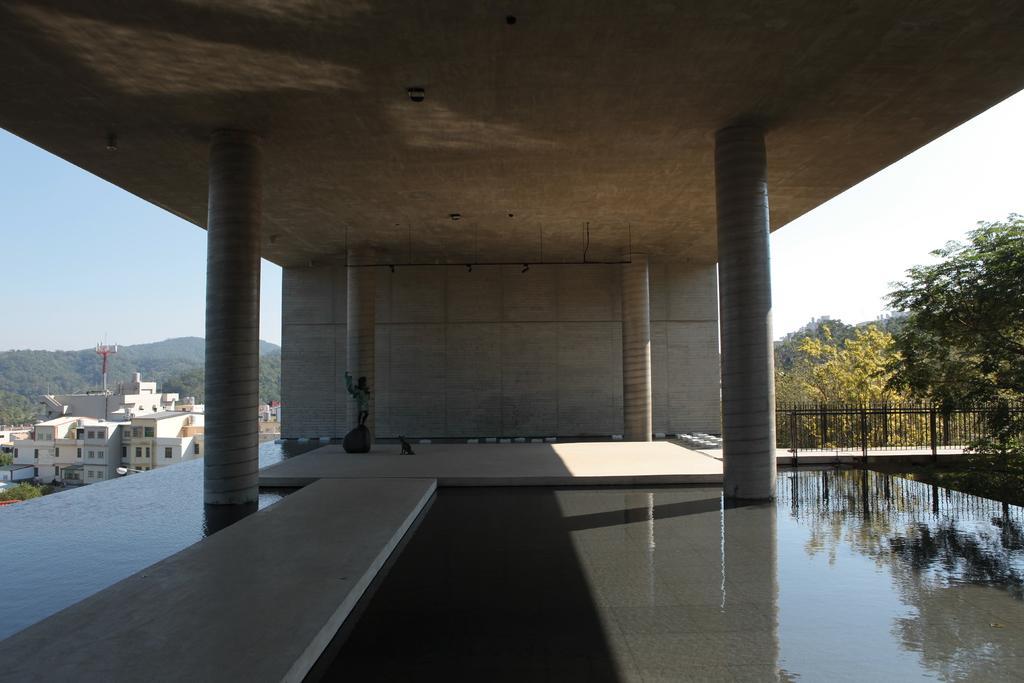Can you describe this image briefly? In the foreground of this image, there is the floor, pillars and the inside roof. On the right, there is a railing, trees and the sky. On the left, there are buildings, mountains and the sky. 